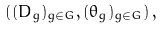<formula> <loc_0><loc_0><loc_500><loc_500>\left ( ( D _ { g } ) _ { g \in G } , ( \theta _ { g } ) _ { g \in G } \right ) ,</formula> 